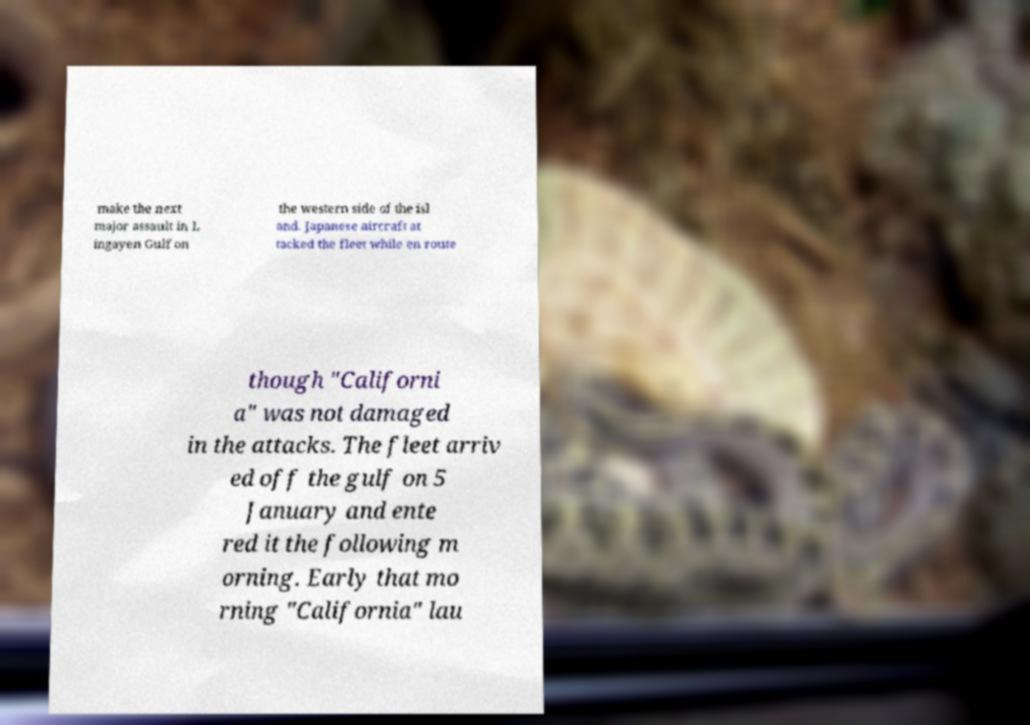For documentation purposes, I need the text within this image transcribed. Could you provide that? make the next major assault in L ingayen Gulf on the western side of the isl and. Japanese aircraft at tacked the fleet while en route though "Californi a" was not damaged in the attacks. The fleet arriv ed off the gulf on 5 January and ente red it the following m orning. Early that mo rning "California" lau 